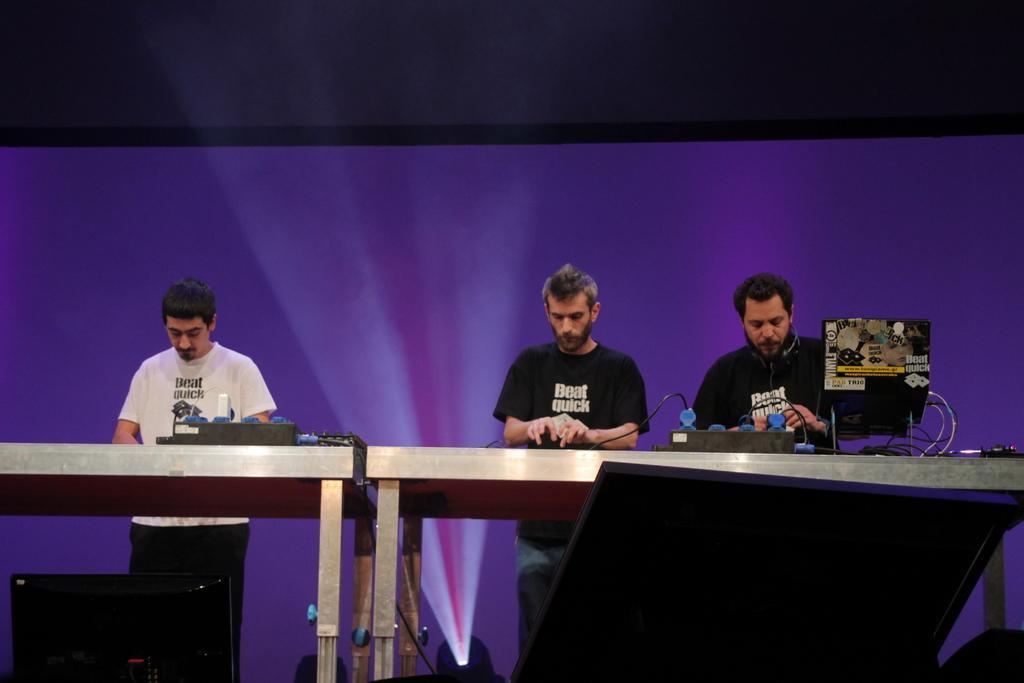Can you describe this image briefly? In this image we can see people standing on the floor and tables are placed in front of them. On the tables we can see electric circuits, cables and a laptop. In the background there is an electric light. 